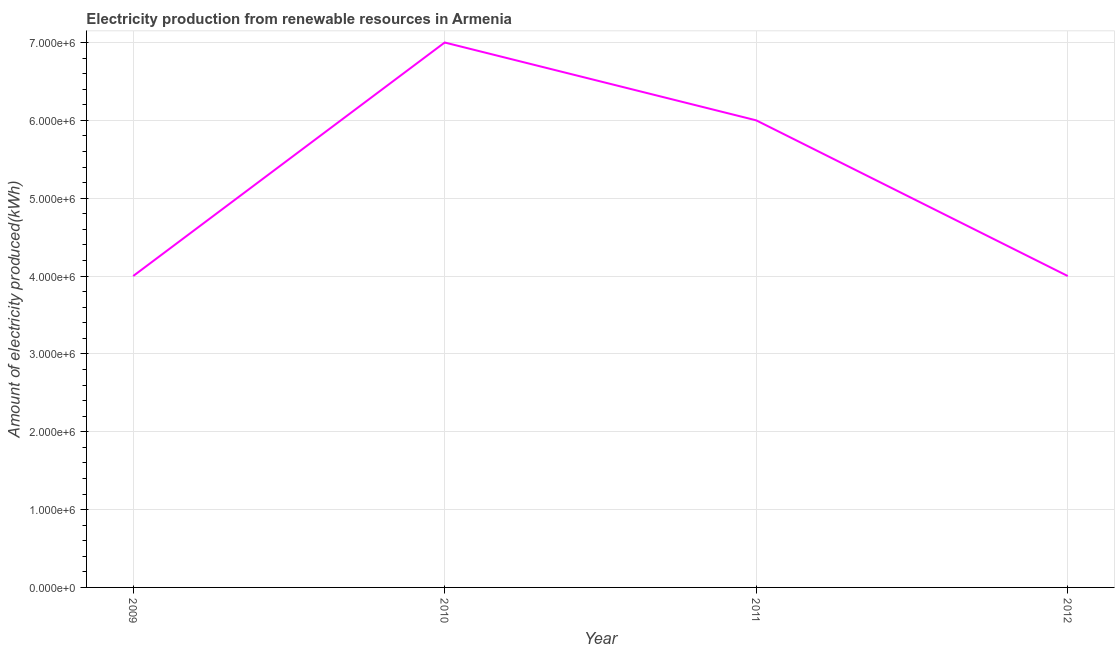What is the amount of electricity produced in 2010?
Your response must be concise. 7.00e+06. Across all years, what is the maximum amount of electricity produced?
Give a very brief answer. 7.00e+06. Across all years, what is the minimum amount of electricity produced?
Offer a terse response. 4.00e+06. In which year was the amount of electricity produced maximum?
Offer a very short reply. 2010. What is the sum of the amount of electricity produced?
Offer a terse response. 2.10e+07. What is the difference between the amount of electricity produced in 2009 and 2010?
Make the answer very short. -3.00e+06. What is the average amount of electricity produced per year?
Provide a short and direct response. 5.25e+06. What is the median amount of electricity produced?
Ensure brevity in your answer.  5.00e+06. What is the ratio of the amount of electricity produced in 2010 to that in 2012?
Offer a very short reply. 1.75. Is the sum of the amount of electricity produced in 2009 and 2010 greater than the maximum amount of electricity produced across all years?
Your response must be concise. Yes. What is the difference between the highest and the lowest amount of electricity produced?
Give a very brief answer. 3.00e+06. In how many years, is the amount of electricity produced greater than the average amount of electricity produced taken over all years?
Keep it short and to the point. 2. How many lines are there?
Offer a terse response. 1. How many years are there in the graph?
Give a very brief answer. 4. Are the values on the major ticks of Y-axis written in scientific E-notation?
Your answer should be very brief. Yes. Does the graph contain grids?
Your answer should be very brief. Yes. What is the title of the graph?
Keep it short and to the point. Electricity production from renewable resources in Armenia. What is the label or title of the Y-axis?
Offer a very short reply. Amount of electricity produced(kWh). What is the Amount of electricity produced(kWh) in 2009?
Offer a very short reply. 4.00e+06. What is the Amount of electricity produced(kWh) in 2011?
Your answer should be compact. 6.00e+06. What is the difference between the Amount of electricity produced(kWh) in 2009 and 2011?
Provide a short and direct response. -2.00e+06. What is the difference between the Amount of electricity produced(kWh) in 2009 and 2012?
Give a very brief answer. 0. What is the difference between the Amount of electricity produced(kWh) in 2010 and 2011?
Offer a terse response. 1.00e+06. What is the difference between the Amount of electricity produced(kWh) in 2011 and 2012?
Offer a very short reply. 2.00e+06. What is the ratio of the Amount of electricity produced(kWh) in 2009 to that in 2010?
Your answer should be compact. 0.57. What is the ratio of the Amount of electricity produced(kWh) in 2009 to that in 2011?
Offer a terse response. 0.67. What is the ratio of the Amount of electricity produced(kWh) in 2010 to that in 2011?
Keep it short and to the point. 1.17. What is the ratio of the Amount of electricity produced(kWh) in 2011 to that in 2012?
Provide a succinct answer. 1.5. 